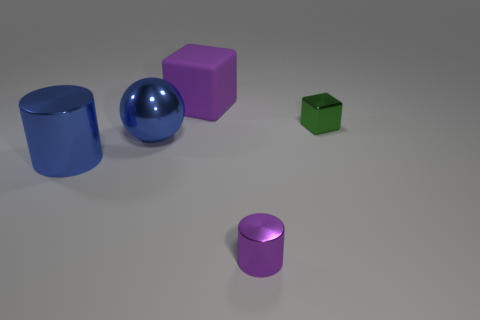Is the number of red metallic cylinders greater than the number of purple rubber things? No, the number of red metallic cylinders is not greater than the number of purple rubber things. In fact, there are no red metallic cylinders visible in the image at all. However, there are two purple objects, one of which appears to be a cube and the other a small cylinder. 